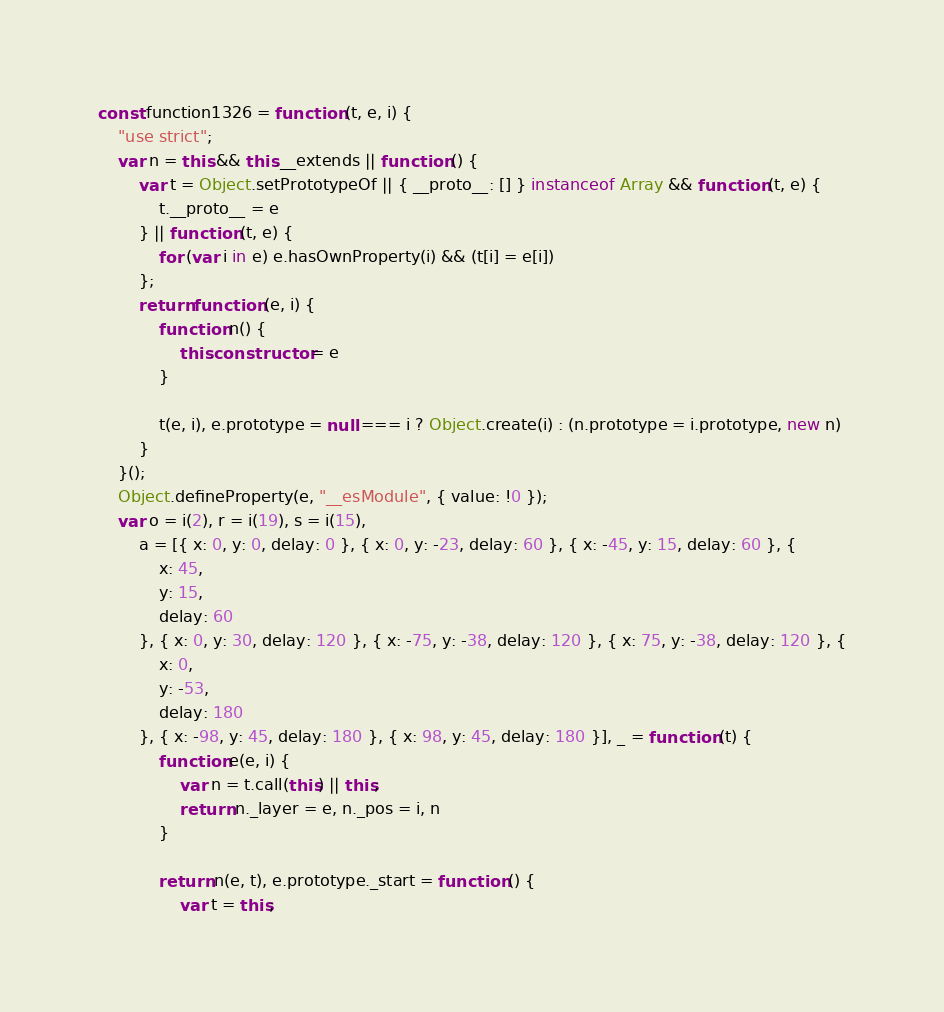Convert code to text. <code><loc_0><loc_0><loc_500><loc_500><_JavaScript_>const function1326 = function (t, e, i) {
    "use strict";
    var n = this && this.__extends || function () {
        var t = Object.setPrototypeOf || { __proto__: [] } instanceof Array && function (t, e) {
            t.__proto__ = e
        } || function (t, e) {
            for (var i in e) e.hasOwnProperty(i) && (t[i] = e[i])
        };
        return function (e, i) {
            function n() {
                this.constructor = e
            }

            t(e, i), e.prototype = null === i ? Object.create(i) : (n.prototype = i.prototype, new n)
        }
    }();
    Object.defineProperty(e, "__esModule", { value: !0 });
    var o = i(2), r = i(19), s = i(15),
        a = [{ x: 0, y: 0, delay: 0 }, { x: 0, y: -23, delay: 60 }, { x: -45, y: 15, delay: 60 }, {
            x: 45,
            y: 15,
            delay: 60
        }, { x: 0, y: 30, delay: 120 }, { x: -75, y: -38, delay: 120 }, { x: 75, y: -38, delay: 120 }, {
            x: 0,
            y: -53,
            delay: 180
        }, { x: -98, y: 45, delay: 180 }, { x: 98, y: 45, delay: 180 }], _ = function (t) {
            function e(e, i) {
                var n = t.call(this) || this;
                return n._layer = e, n._pos = i, n
            }

            return n(e, t), e.prototype._start = function () {
                var t = this;</code> 